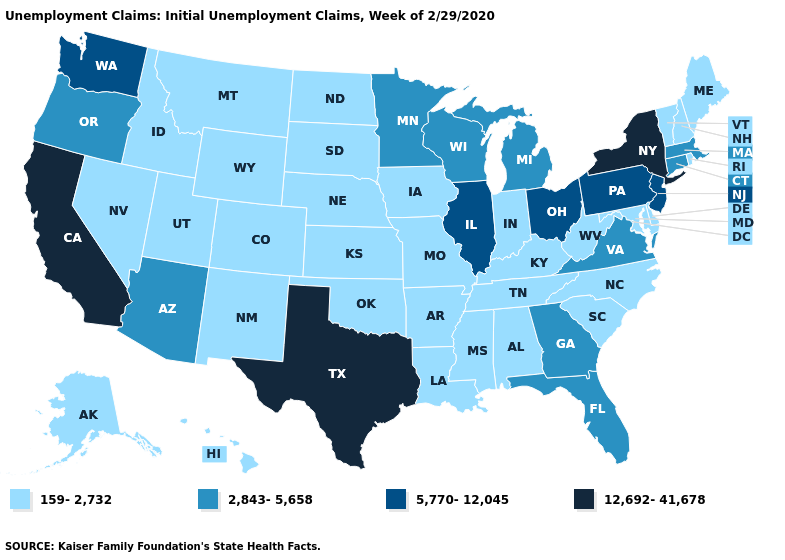Name the states that have a value in the range 5,770-12,045?
Answer briefly. Illinois, New Jersey, Ohio, Pennsylvania, Washington. Name the states that have a value in the range 2,843-5,658?
Answer briefly. Arizona, Connecticut, Florida, Georgia, Massachusetts, Michigan, Minnesota, Oregon, Virginia, Wisconsin. Among the states that border Arizona , which have the lowest value?
Keep it brief. Colorado, Nevada, New Mexico, Utah. Which states have the highest value in the USA?
Write a very short answer. California, New York, Texas. What is the value of Kansas?
Answer briefly. 159-2,732. What is the highest value in the USA?
Write a very short answer. 12,692-41,678. Name the states that have a value in the range 2,843-5,658?
Concise answer only. Arizona, Connecticut, Florida, Georgia, Massachusetts, Michigan, Minnesota, Oregon, Virginia, Wisconsin. What is the value of California?
Quick response, please. 12,692-41,678. What is the value of New Mexico?
Quick response, please. 159-2,732. Does Wyoming have a higher value than Colorado?
Keep it brief. No. Which states have the highest value in the USA?
Concise answer only. California, New York, Texas. Among the states that border Utah , does Arizona have the lowest value?
Quick response, please. No. Among the states that border New Mexico , does Oklahoma have the highest value?
Short answer required. No. What is the value of Nebraska?
Quick response, please. 159-2,732. 